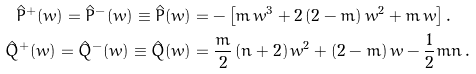Convert formula to latex. <formula><loc_0><loc_0><loc_500><loc_500>\hat { P } ^ { + } ( w ) = \hat { P } ^ { - } ( w ) \equiv \hat { P } ( w ) & = - \left [ m \, w ^ { 3 } + 2 \, ( 2 - m ) \, w ^ { 2 } + m \, w \right ] . \\ \hat { Q } ^ { + } ( w ) = \hat { Q } ^ { - } ( w ) \equiv \hat { Q } ( w ) & = \frac { m } { 2 } \, ( n + 2 ) \, w ^ { 2 } + ( 2 - m ) \, w - \frac { 1 } { 2 } m n \, .</formula> 